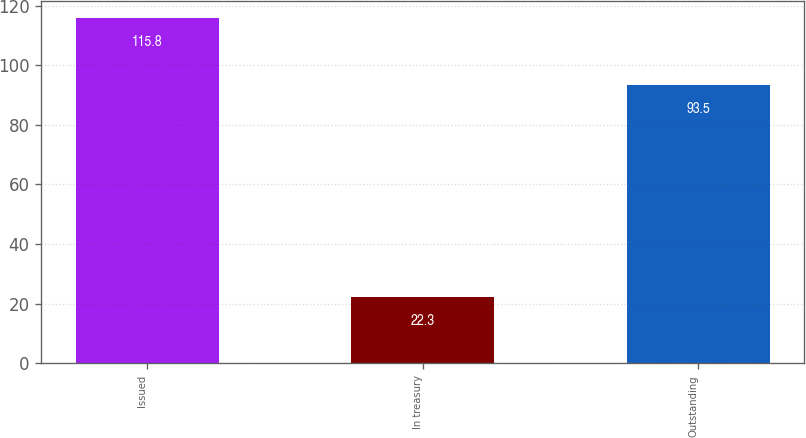Convert chart to OTSL. <chart><loc_0><loc_0><loc_500><loc_500><bar_chart><fcel>Issued<fcel>In treasury<fcel>Outstanding<nl><fcel>115.8<fcel>22.3<fcel>93.5<nl></chart> 